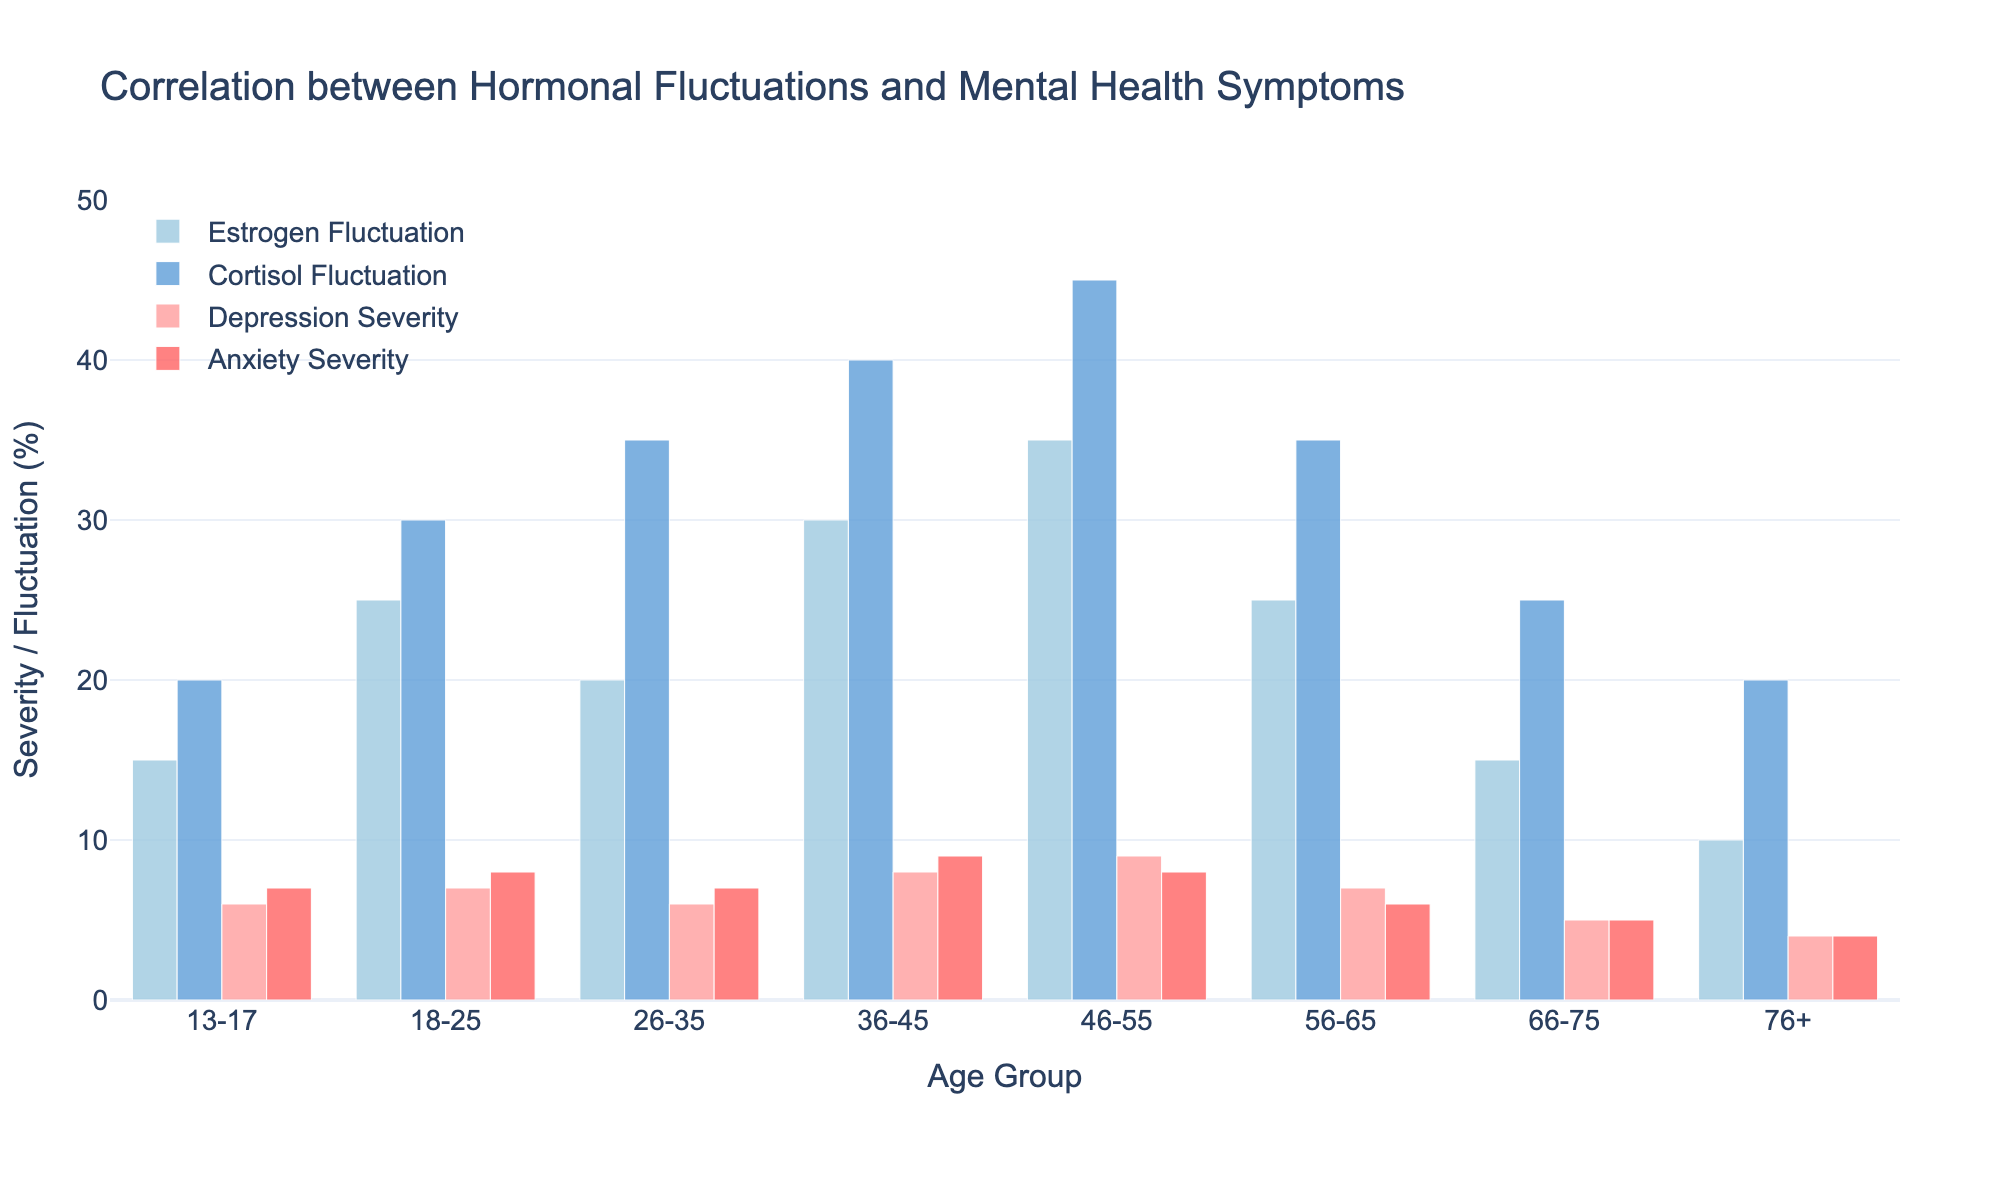Which age group has the highest estrogen fluctuation? The figure shows the estrogen fluctuation percentages for different age groups. The bar representing the estrogen fluctuation is highest for the 46-55 age group.
Answer: 46-55 What is the difference in cortisol fluctuation between the age groups 18-25 and 36-45? To find the difference in cortisol fluctuation, subtract the cortisol fluctuation of the 36-45 age group (40%) from the 18-25 age group (30%).
Answer: 10% Which age group has the lowest depression severity? By looking at the depression severity bars in the figure, the lowest severity is in the 76+ age group.
Answer: 76+ Is anxiety severity higher in the 36-45 age group or in the 56-65 age group? The figure shows that the anxiety severity for the 36-45 age group is 9, while for the 56-65 age group it is 6. Therefore, the 36-45 age group has higher anxiety severity.
Answer: 36-45 How does the depression severity in the 66-75 age group compare to the 18-25 age group? The figure shows that depression severity for the 66-75 age group is 5, while it is 7 for the 18-25 age group. Thus, the depression severity is lower in the 66-75 age group compared to the 18-25 age group.
Answer: lower What is the average estrogen fluctuation across all age groups? Add up all the estrogen fluctuation percentages (15 + 25 + 20 + 30 + 35 + 25 + 15 + 10 = 175) and divide by the number of age groups (8).
Answer: 21.875% Which age group exhibits the highest consistency between depression and anxiety severity? The figure shows depression and anxiety severities for each age group. The 46-55 age group has the most similar values with depression at 9 and anxiety at 8, indicating the highest consistency.
Answer: 46-55 What is the combined severity (sum) of depression and anxiety for the 13-17 age group? Add the depression severity (6) and anxiety severity (7) for the 13-17 age group.
Answer: 13 Do hormonal fluctuations correlate with higher mental health severity in older age groups? By examining the figure, it's noticeable that both estrogen and cortisol fluctuations and the severities of depression and anxiety tend to be higher in older age groups (e.g., 36-45 and 46-55) compared to younger groups.
Answer: Yes 